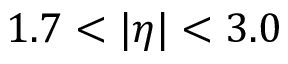<formula> <loc_0><loc_0><loc_500><loc_500>1 . 7 < | \eta | < 3 . 0</formula> 